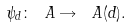<formula> <loc_0><loc_0><loc_500><loc_500>\psi _ { d } \colon \ A \rightarrow \ A ( d ) .</formula> 